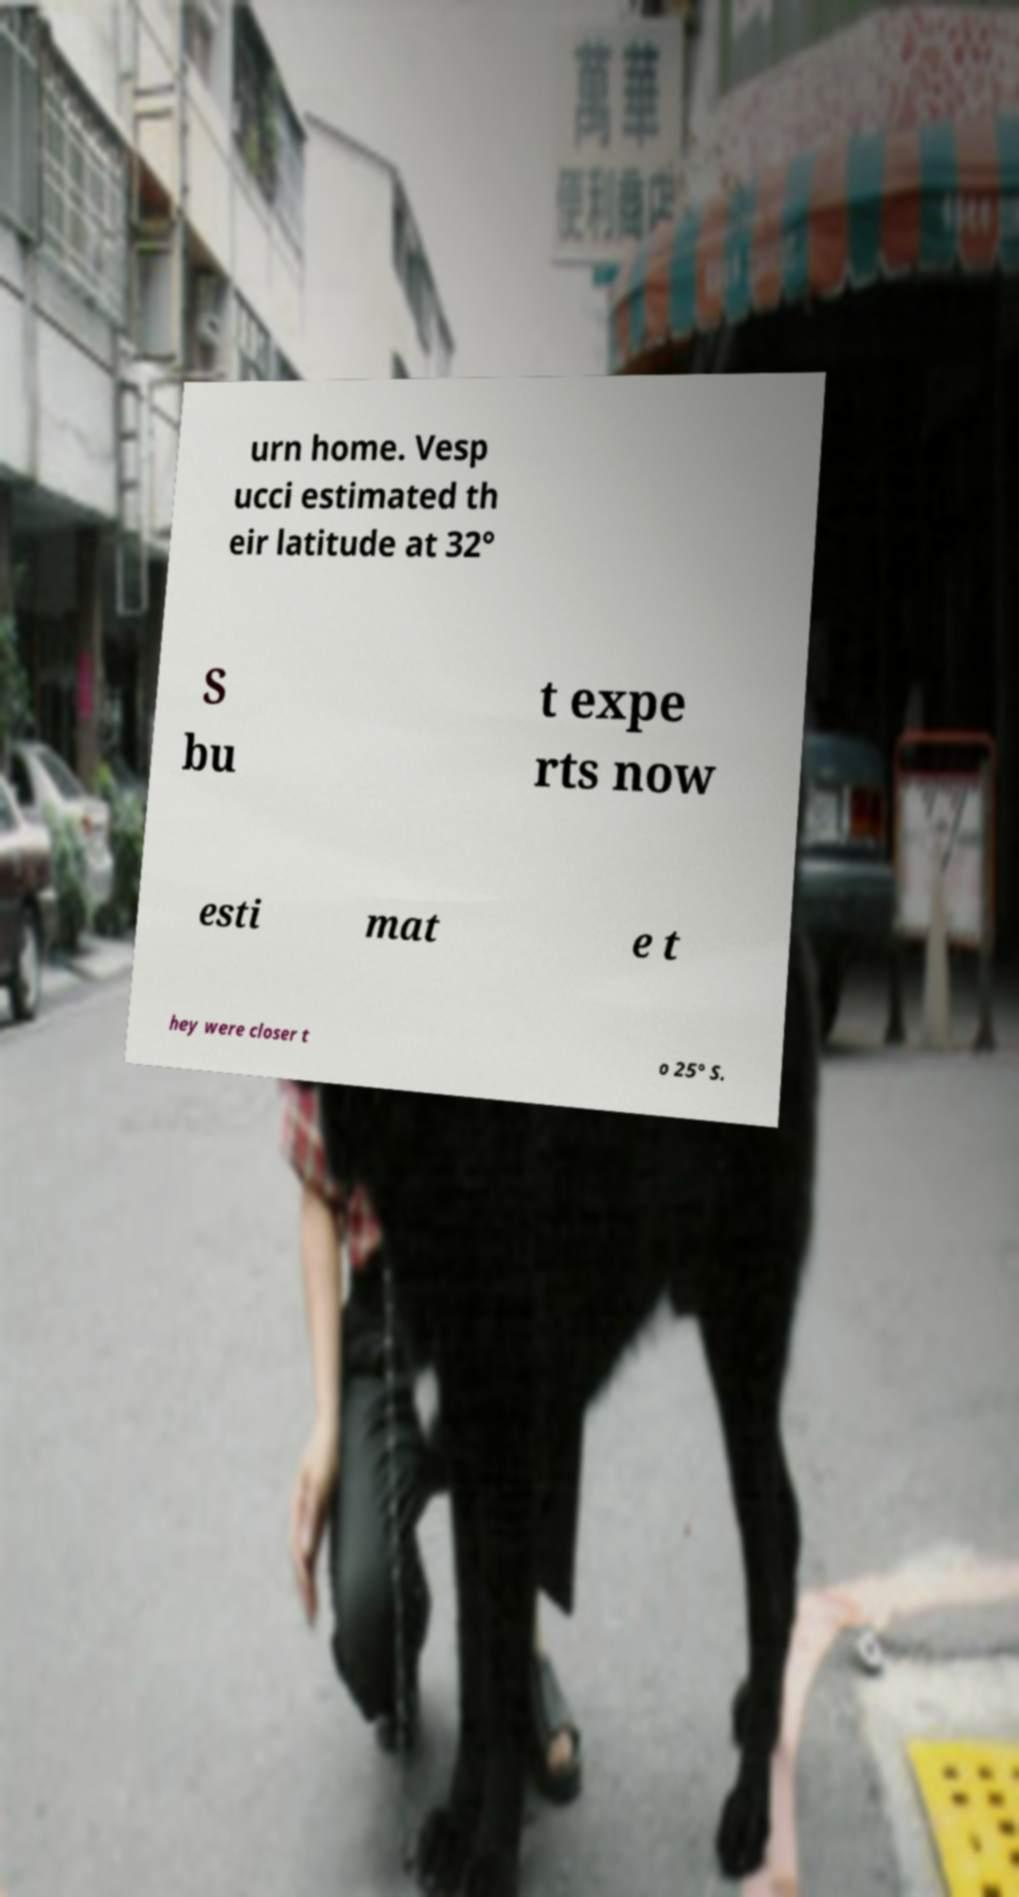Please identify and transcribe the text found in this image. urn home. Vesp ucci estimated th eir latitude at 32° S bu t expe rts now esti mat e t hey were closer t o 25° S. 